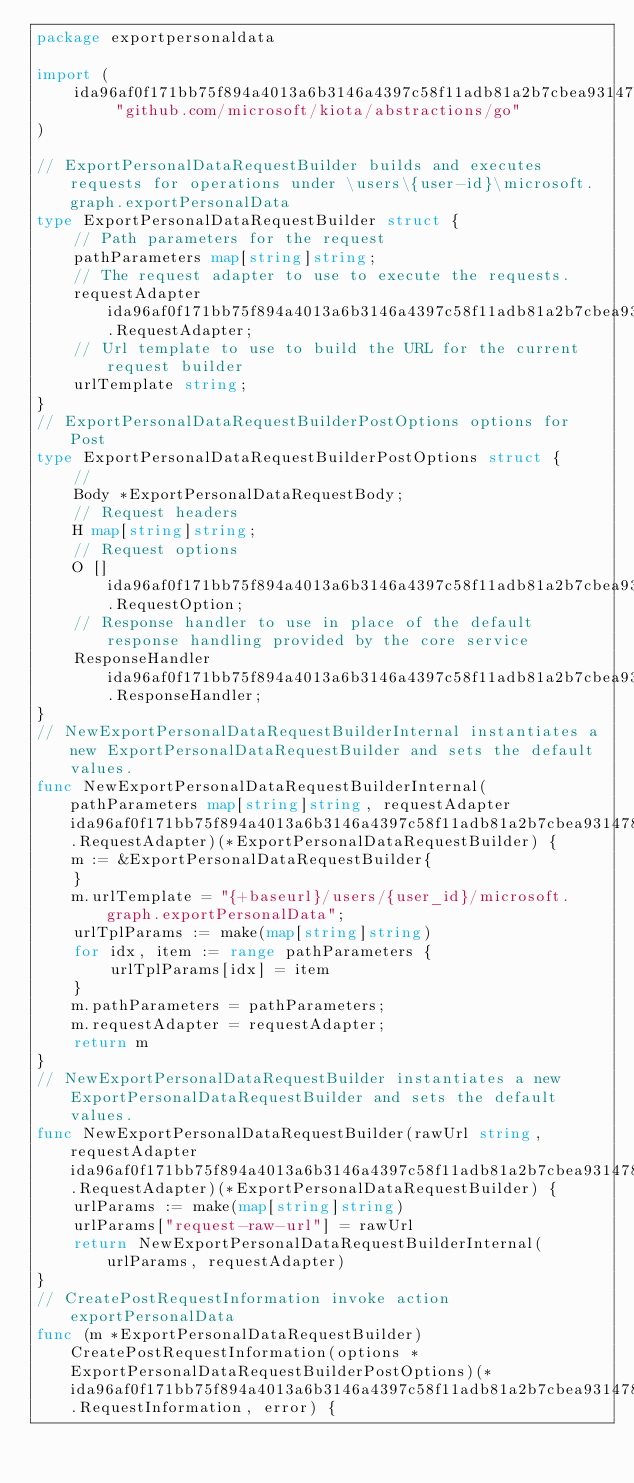Convert code to text. <code><loc_0><loc_0><loc_500><loc_500><_Go_>package exportpersonaldata

import (
    ida96af0f171bb75f894a4013a6b3146a4397c58f11adb81a2b7cbea9314783a9 "github.com/microsoft/kiota/abstractions/go"
)

// ExportPersonalDataRequestBuilder builds and executes requests for operations under \users\{user-id}\microsoft.graph.exportPersonalData
type ExportPersonalDataRequestBuilder struct {
    // Path parameters for the request
    pathParameters map[string]string;
    // The request adapter to use to execute the requests.
    requestAdapter ida96af0f171bb75f894a4013a6b3146a4397c58f11adb81a2b7cbea9314783a9.RequestAdapter;
    // Url template to use to build the URL for the current request builder
    urlTemplate string;
}
// ExportPersonalDataRequestBuilderPostOptions options for Post
type ExportPersonalDataRequestBuilderPostOptions struct {
    // 
    Body *ExportPersonalDataRequestBody;
    // Request headers
    H map[string]string;
    // Request options
    O []ida96af0f171bb75f894a4013a6b3146a4397c58f11adb81a2b7cbea9314783a9.RequestOption;
    // Response handler to use in place of the default response handling provided by the core service
    ResponseHandler ida96af0f171bb75f894a4013a6b3146a4397c58f11adb81a2b7cbea9314783a9.ResponseHandler;
}
// NewExportPersonalDataRequestBuilderInternal instantiates a new ExportPersonalDataRequestBuilder and sets the default values.
func NewExportPersonalDataRequestBuilderInternal(pathParameters map[string]string, requestAdapter ida96af0f171bb75f894a4013a6b3146a4397c58f11adb81a2b7cbea9314783a9.RequestAdapter)(*ExportPersonalDataRequestBuilder) {
    m := &ExportPersonalDataRequestBuilder{
    }
    m.urlTemplate = "{+baseurl}/users/{user_id}/microsoft.graph.exportPersonalData";
    urlTplParams := make(map[string]string)
    for idx, item := range pathParameters {
        urlTplParams[idx] = item
    }
    m.pathParameters = pathParameters;
    m.requestAdapter = requestAdapter;
    return m
}
// NewExportPersonalDataRequestBuilder instantiates a new ExportPersonalDataRequestBuilder and sets the default values.
func NewExportPersonalDataRequestBuilder(rawUrl string, requestAdapter ida96af0f171bb75f894a4013a6b3146a4397c58f11adb81a2b7cbea9314783a9.RequestAdapter)(*ExportPersonalDataRequestBuilder) {
    urlParams := make(map[string]string)
    urlParams["request-raw-url"] = rawUrl
    return NewExportPersonalDataRequestBuilderInternal(urlParams, requestAdapter)
}
// CreatePostRequestInformation invoke action exportPersonalData
func (m *ExportPersonalDataRequestBuilder) CreatePostRequestInformation(options *ExportPersonalDataRequestBuilderPostOptions)(*ida96af0f171bb75f894a4013a6b3146a4397c58f11adb81a2b7cbea9314783a9.RequestInformation, error) {</code> 